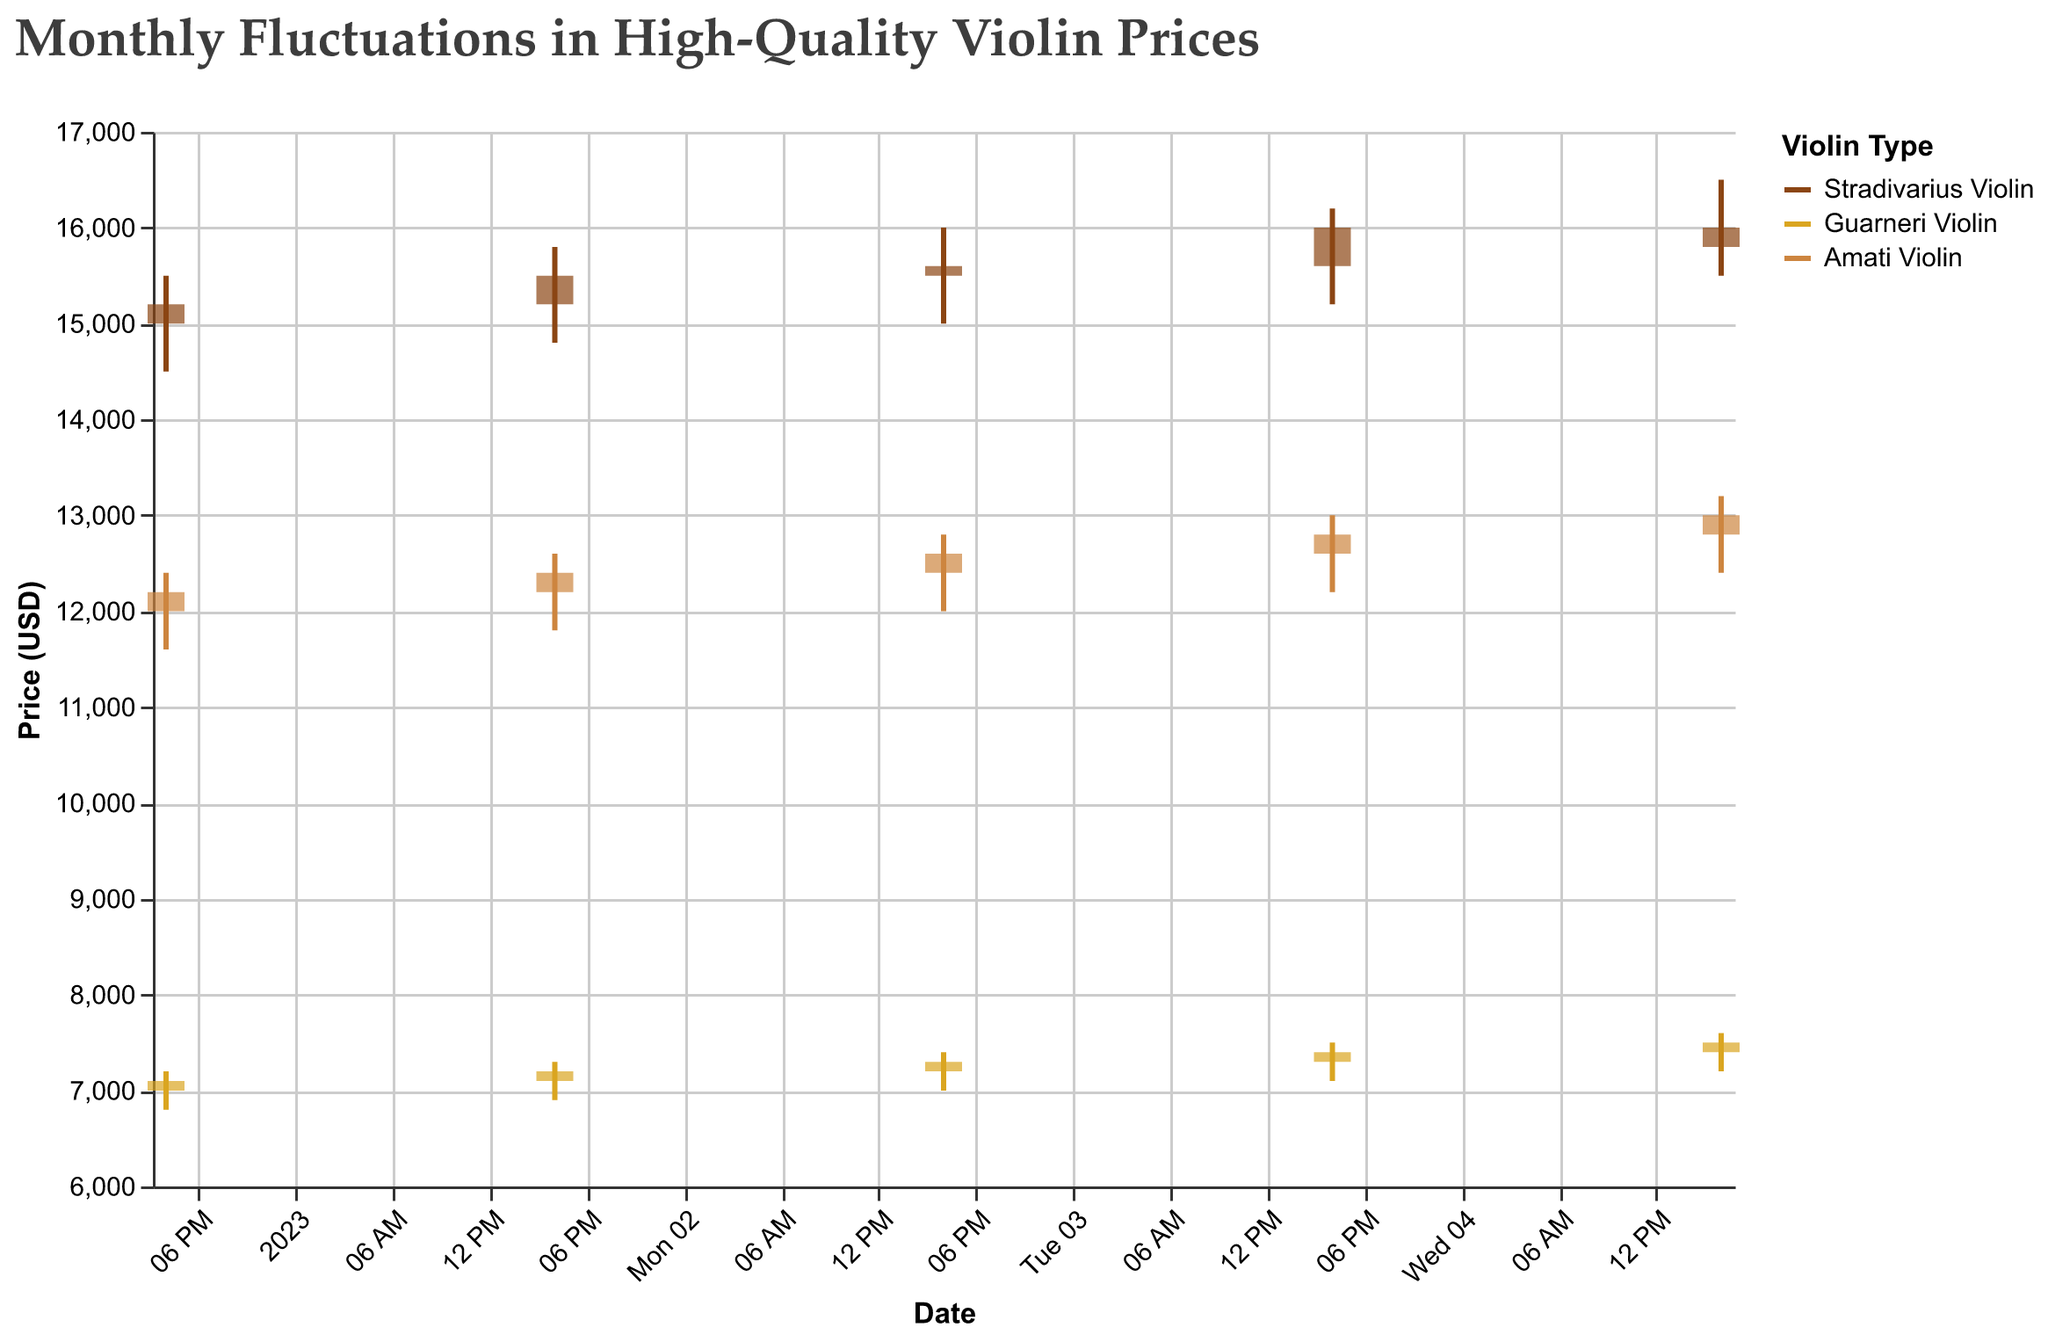what is the title of the figure? The title is located at the top of the figure and reads "Monthly Fluctuations in High-Quality Violin Prices"
Answer: Monthly Fluctuations in High-Quality Violin Prices Which violin type had the highest price at any point in January 2023? By observing the "High" value for each violin, the highest price recorded is 16500 for the Stradivarius Violin on January 5, 2023
Answer: Stradivarius Violin How many data points are plotted for each violin? Each violin has a data point for each date, and since there are five dates listed, each violin has 5 data points
Answer: 5 Which violin had the smallest range of prices on January 3, 2023? The range of prices is calculated by subtracting the Low value from the High value for each violin on January 3, 2023: Stradivarius Violin (16000 - 15000 = 1000), Guarneri Violin (7400 - 7000 = 400), and Amati Violin (12800 - 12000 = 800). The smallest range is for the Guarneri Violin
Answer: Guarneri Violin Which violin had the highest closing price on January 2, 2023? The closing prices on January 2, 2023, are 15500 (Stradivarius Violin), 7200 (Guarneri Violin), and 12400 (Amati Violin). The highest of these is 15500, for the Stradivarius Violin
Answer: Stradivarius Violin Compare the price range of the Guarneri Violin and the Amati Violin on January 4, 2023. Which one was larger? For the Guarneri Violin on January 4, 2023, the price range is High - Low = 7500 - 7100 = 400. For the Amati Violin on January 4, 2023, the price range is High - Low = 13000 - 12200 = 800. The range for the Amati Violin is larger
Answer: Amati Violin What is the average closing price of the Amati Violin over the five days? To calculate the average, sum the closing prices (12200 + 12400 + 12600 + 12800 + 13000) and divide by 5. The sum is 63000, and the average is 63000 / 5 = 12600
Answer: 12600 Did the Stradivarius Violin's price decrease on any day compared to the previous day? Comparing the closing prices day-to-day: from January 4 to January 5, the closing price decreased from 16000 to 15800
Answer: Yes How does the highest price of the Stradivarius Violin compare to the highest price of the Guarneri Violin on January 4, 2023? The highest price on January 4, 2023, is 16200 for the Stradivarius Violin and 7500 for the Guarneri Violin. 16200 is greater than 7500
Answer: Stradivarius Violin is higher What was the price difference between the highest and lowest prices of the Stradivarius Violin on January 1, 2023? The price difference is calculated as High - Low. For January 1, 2023, it is 15500 - 14500 = 1000
Answer: 1000 